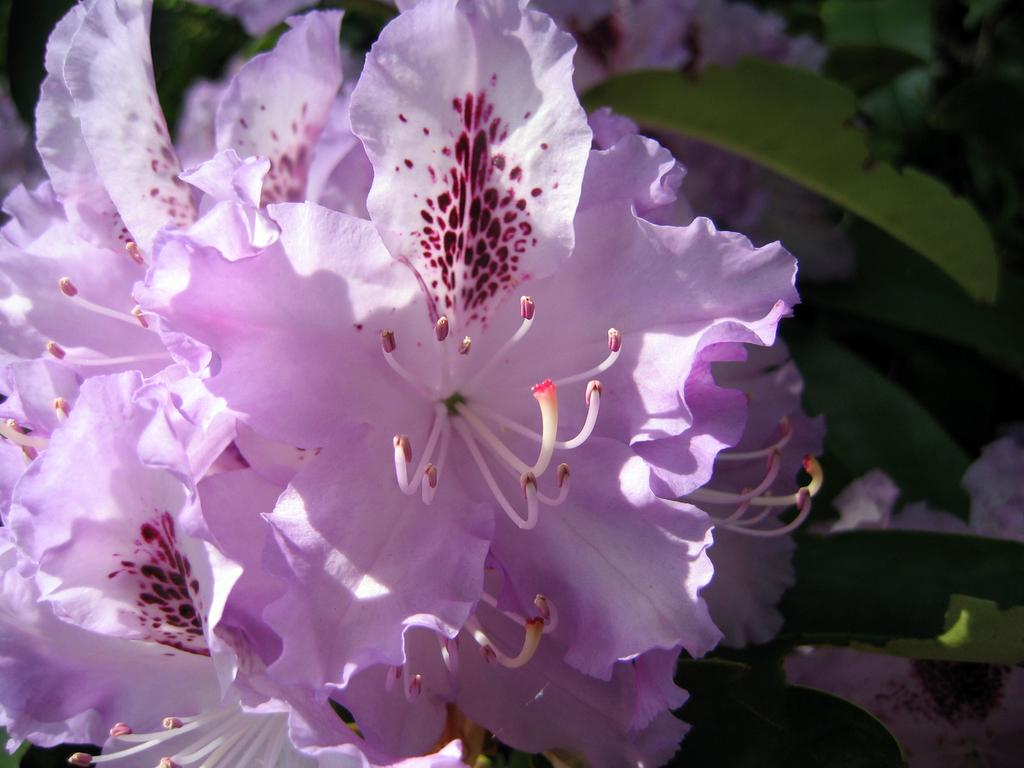What is the main subject of the image? There is a flower in the image. What color is the flower? The flower is pink in color. On which side of the image is the flower located? The flower is on the left side of the image. What other elements are present in the image besides the flower? There are green leaves in the image. Where are the green leaves located in the image? The green leaves are on the right side of the image. How many wings can be seen on the rat in the image? There is no rat present in the image, and therefore no wings can be seen. 